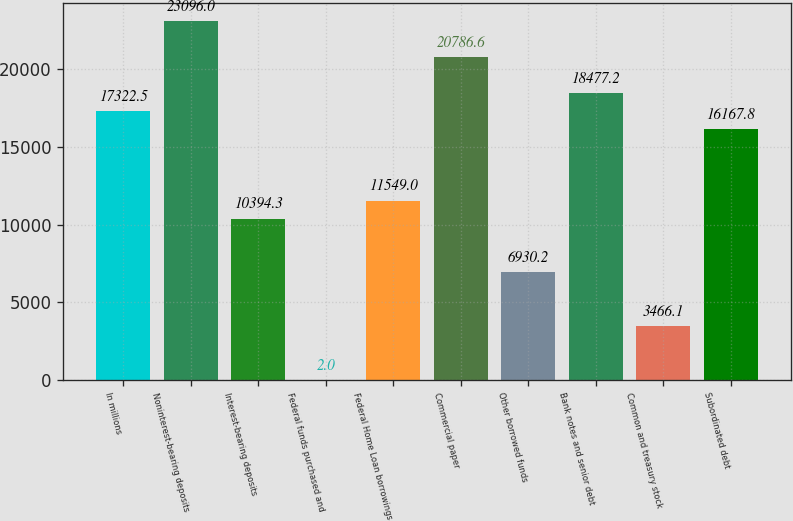Convert chart to OTSL. <chart><loc_0><loc_0><loc_500><loc_500><bar_chart><fcel>In millions<fcel>Noninterest-bearing deposits<fcel>Interest-bearing deposits<fcel>Federal funds purchased and<fcel>Federal Home Loan borrowings<fcel>Commercial paper<fcel>Other borrowed funds<fcel>Bank notes and senior debt<fcel>Common and treasury stock<fcel>Subordinated debt<nl><fcel>17322.5<fcel>23096<fcel>10394.3<fcel>2<fcel>11549<fcel>20786.6<fcel>6930.2<fcel>18477.2<fcel>3466.1<fcel>16167.8<nl></chart> 